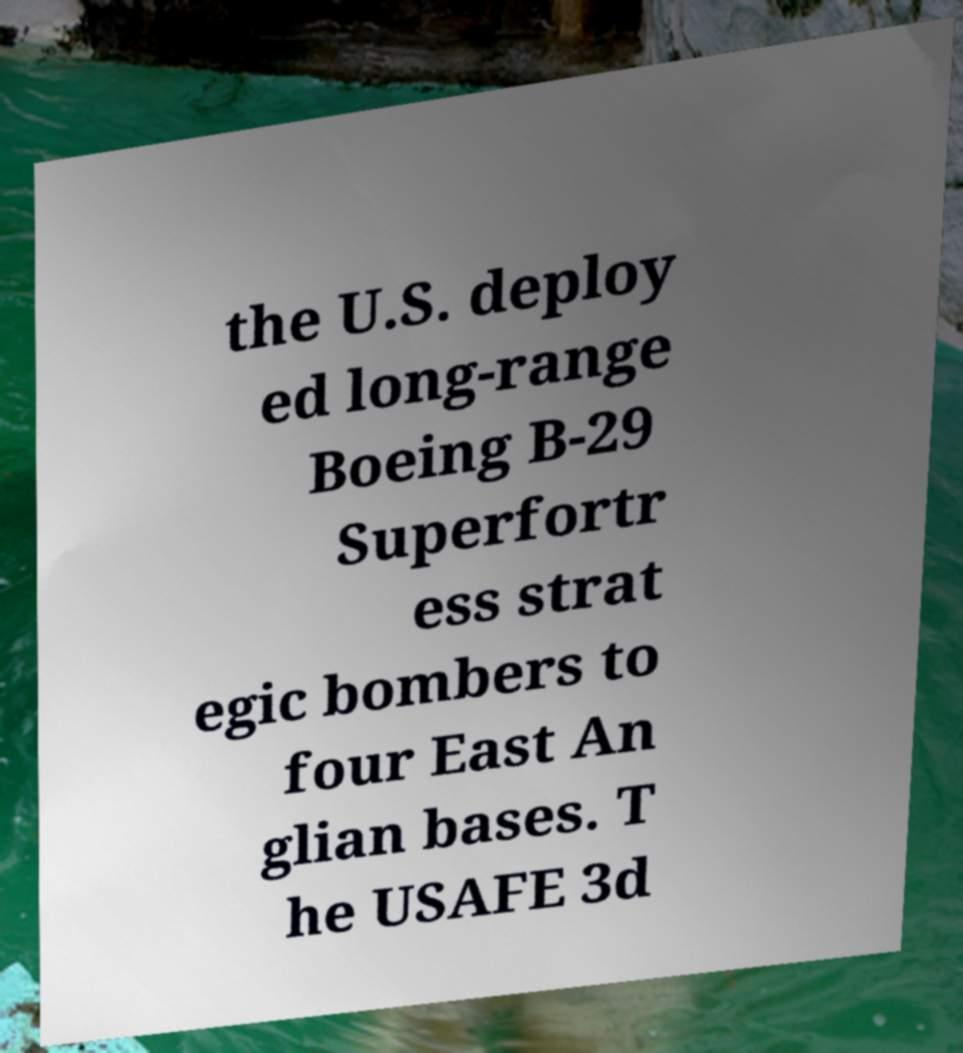There's text embedded in this image that I need extracted. Can you transcribe it verbatim? the U.S. deploy ed long-range Boeing B-29 Superfortr ess strat egic bombers to four East An glian bases. T he USAFE 3d 